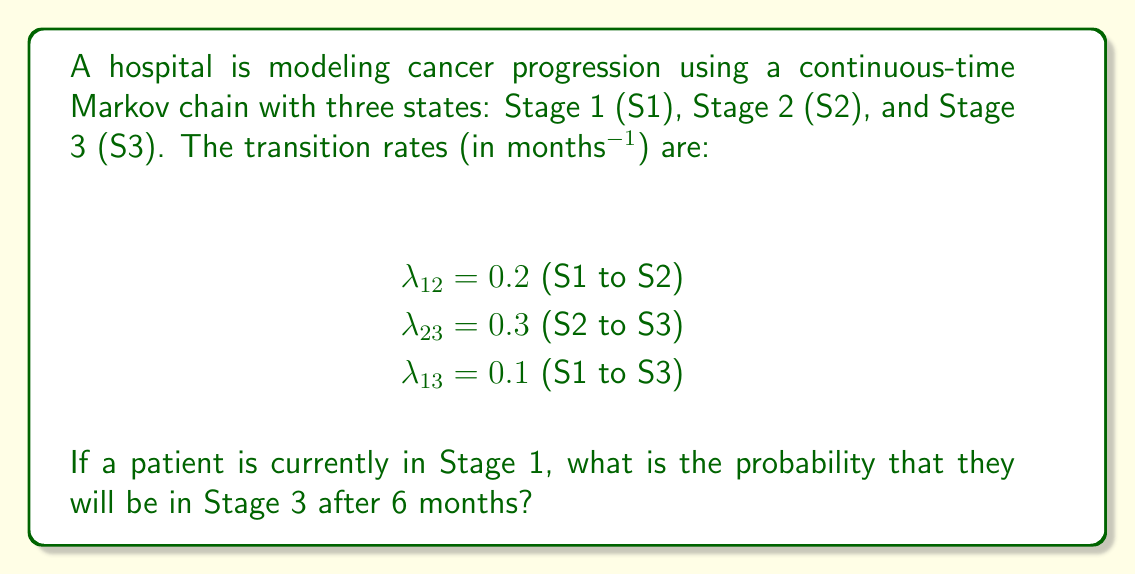Teach me how to tackle this problem. To solve this problem, we'll use the Chapman-Kolmogorov equations for a continuous-time Markov chain.

Step 1: Set up the transition rate matrix Q.
$$Q = \begin{bmatrix}
-(\lambda_{12} + \lambda_{13}) & \lambda_{12} & \lambda_{13} \\
0 & -\lambda_{23} & \lambda_{23} \\
0 & 0 & 0
\end{bmatrix}$$

$$Q = \begin{bmatrix}
-0.3 & 0.2 & 0.1 \\
0 & -0.3 & 0.3 \\
0 & 0 & 0
\end{bmatrix}$$

Step 2: Calculate the transition probability matrix P(t) using the matrix exponential.
$$P(t) = e^{Qt}$$

Step 3: For t = 6 months, calculate P(6) using a computer algebra system or numerical approximation.

$$P(6) \approx \begin{bmatrix}
0.1653 & 0.5407 & 0.2940 \\
0 & 0.1653 & 0.8347 \\
0 & 0 & 1
\end{bmatrix}$$

Step 4: The probability of being in Stage 3 after 6 months, starting from Stage 1, is given by the element P_{13}(6) = 0.2940.
Answer: 0.2940 